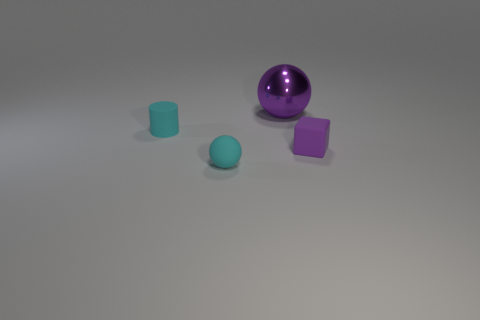Add 4 big rubber balls. How many objects exist? 8 Subtract all cylinders. How many objects are left? 3 Add 4 big things. How many big things exist? 5 Subtract 0 brown balls. How many objects are left? 4 Subtract all small brown metallic cubes. Subtract all purple matte cubes. How many objects are left? 3 Add 2 big purple objects. How many big purple objects are left? 3 